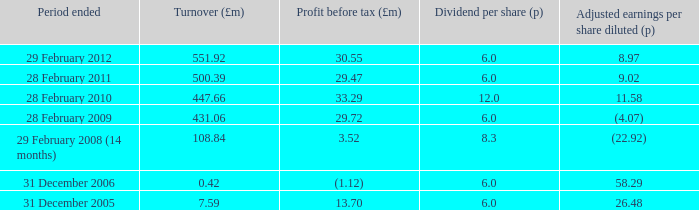42? 1.0. 